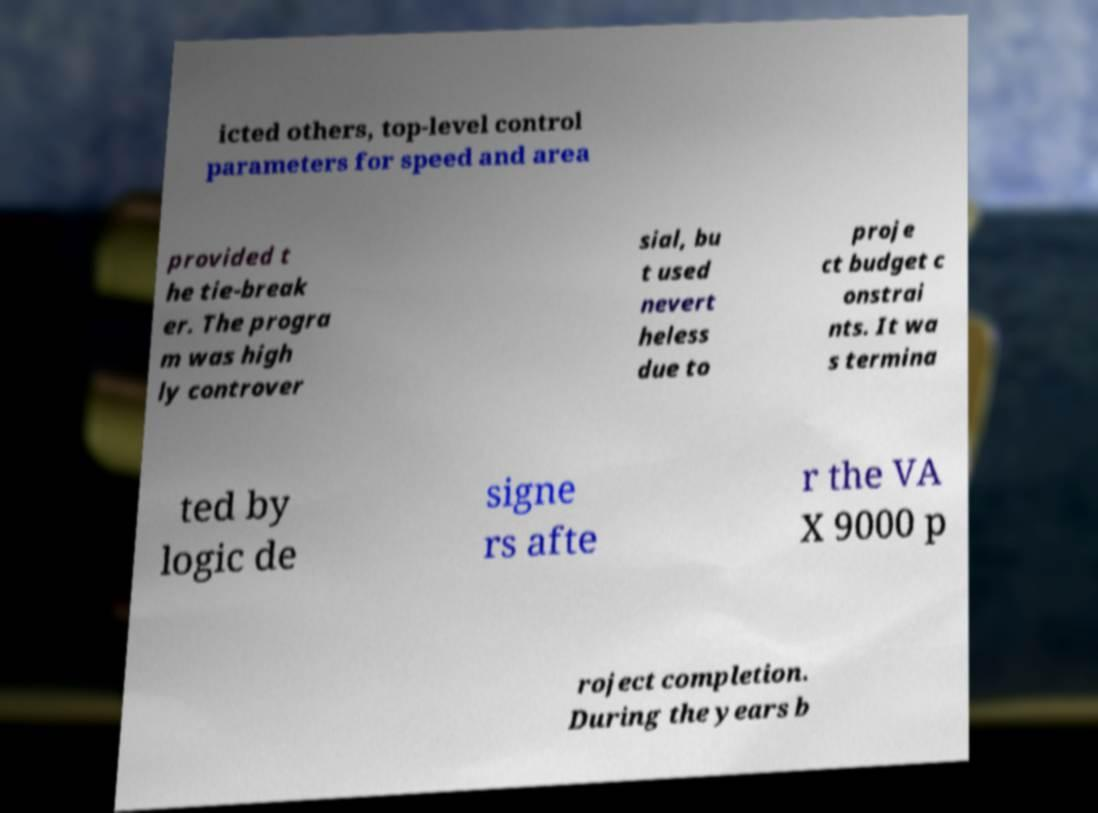Can you accurately transcribe the text from the provided image for me? icted others, top-level control parameters for speed and area provided t he tie-break er. The progra m was high ly controver sial, bu t used nevert heless due to proje ct budget c onstrai nts. It wa s termina ted by logic de signe rs afte r the VA X 9000 p roject completion. During the years b 